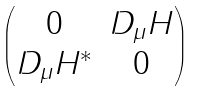Convert formula to latex. <formula><loc_0><loc_0><loc_500><loc_500>\begin{pmatrix} 0 & D _ { \mu } H \\ D _ { \mu } H ^ { * } & 0 \end{pmatrix}</formula> 